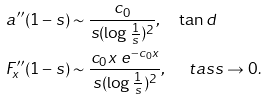Convert formula to latex. <formula><loc_0><loc_0><loc_500><loc_500>a ^ { \prime \prime } ( 1 - s ) & \sim \frac { c _ { 0 } } { s ( \log \frac { 1 } { s } ) ^ { 2 } } , \quad \tan d \\ F _ { x } ^ { \prime \prime } ( 1 - s ) & \sim \frac { c _ { 0 } x \ e ^ { - c _ { 0 } x } } { s ( \log \frac { 1 } { s } ) ^ { 2 } } , \quad \ t a s s \to 0 .</formula> 